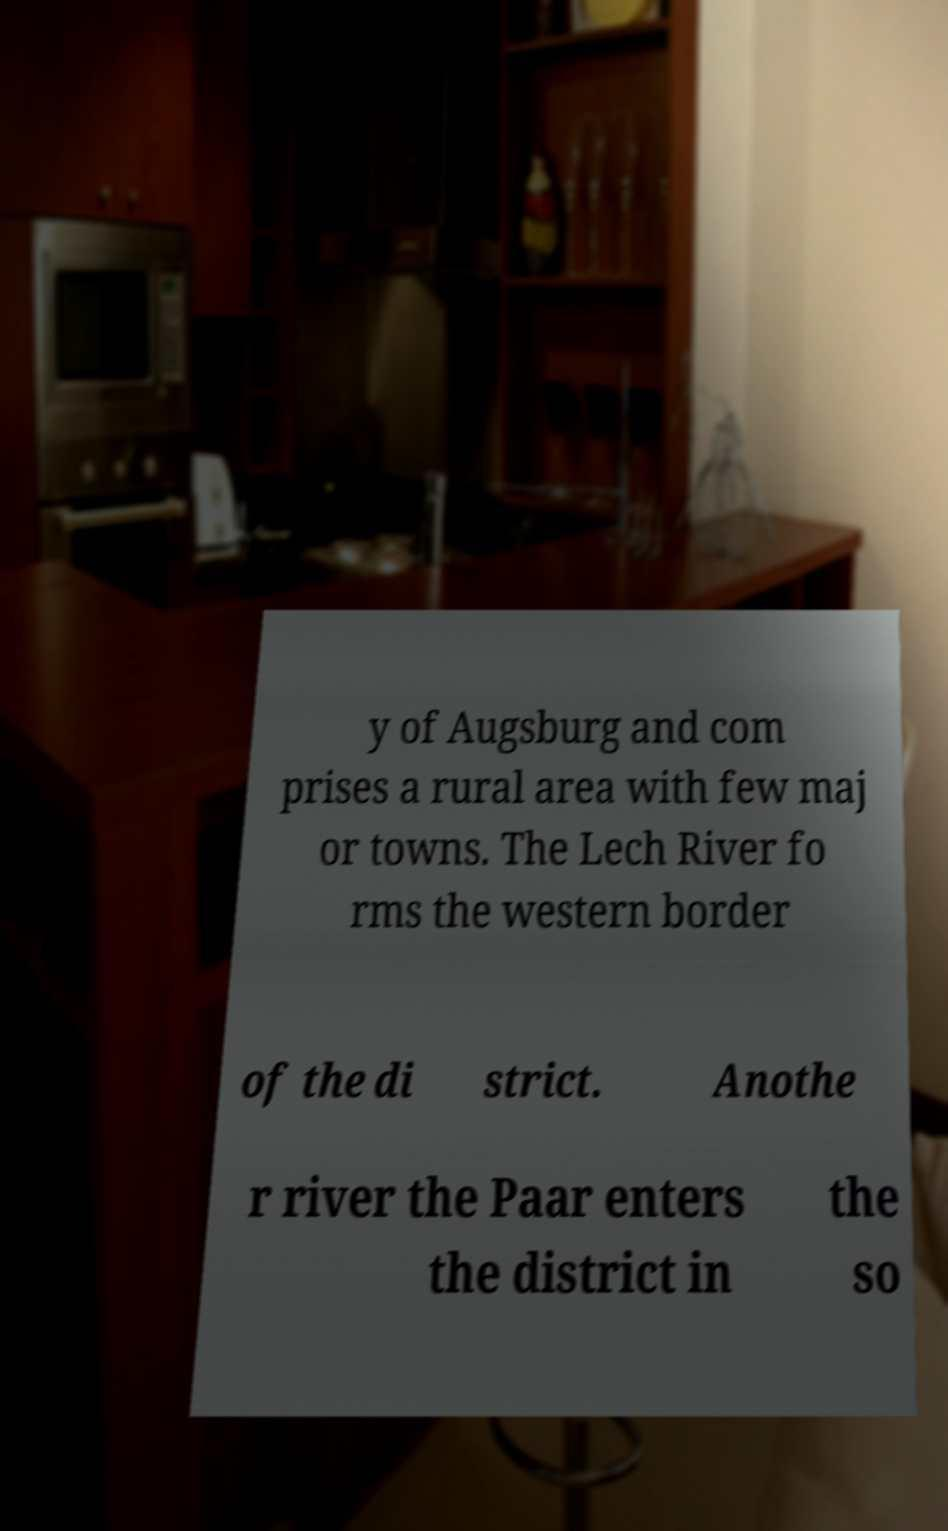Can you accurately transcribe the text from the provided image for me? y of Augsburg and com prises a rural area with few maj or towns. The Lech River fo rms the western border of the di strict. Anothe r river the Paar enters the district in the so 